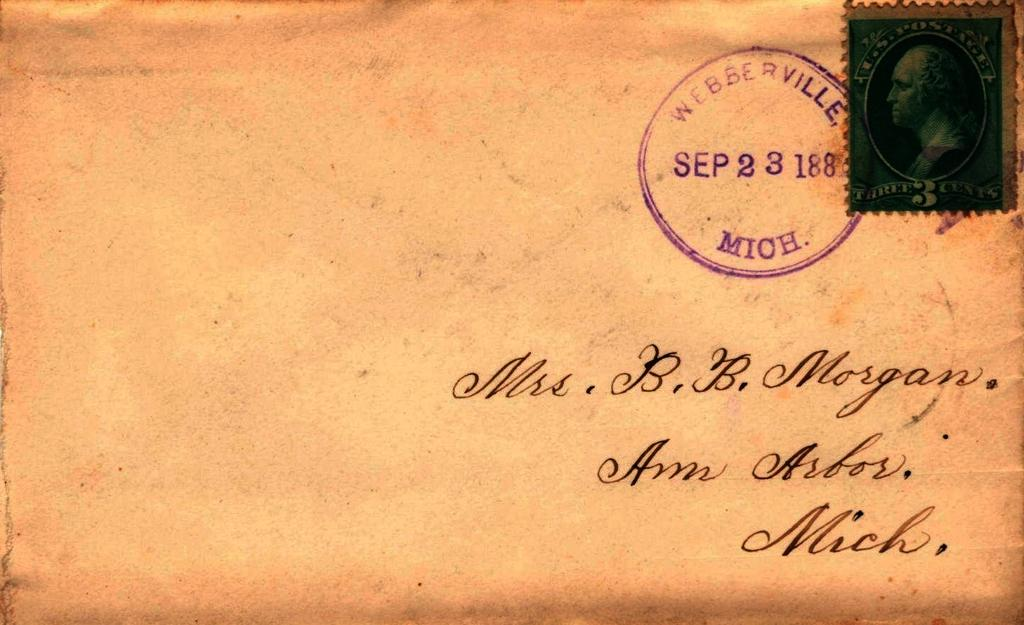<image>
Describe the image concisely. An old letter addressed to a Mrs. B.B. Morgan 